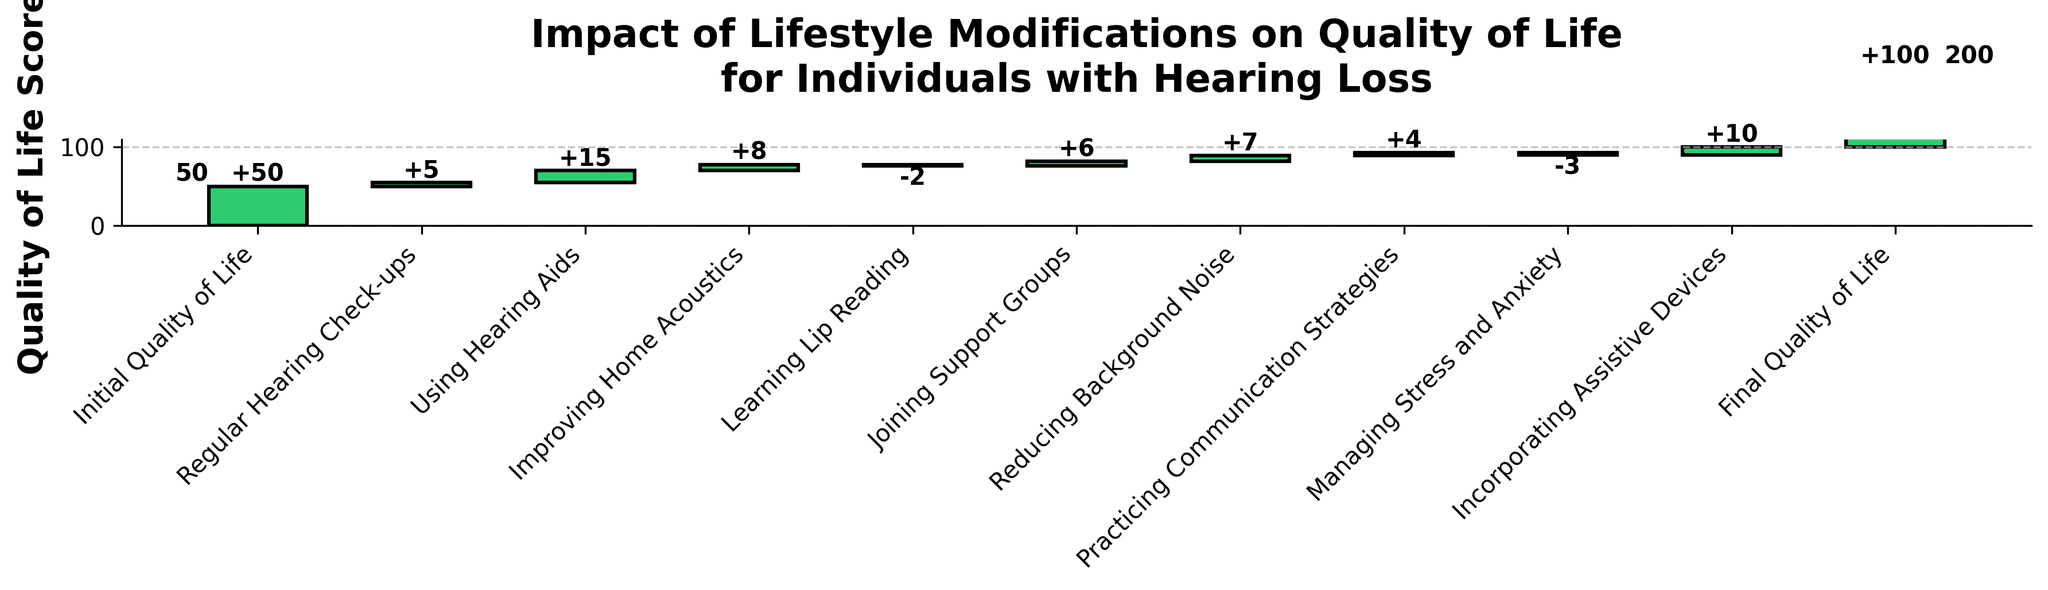What is the title of the chart? The title of the chart is usually placed at the top of the figure. It provides an overview of what the chart is about. In this case, the title is "Impact of Lifestyle Modifications on Quality of Life for Individuals with Hearing Loss".
Answer: Impact of Lifestyle Modifications on Quality of Life for Individuals with Hearing Loss How many steps are shown in the waterfall chart? Count the number of steps listed on the x-axis. Each step represents a different modification.
Answer: 10 What is the total improvement in Quality of Life Score from "Using Hearing Aids"? Look for the bar labeled "Using Hearing Aids" and identify the value associated with it. The value is indicated as +15.
Answer: +15 Which modification has a negative impact on the Quality of Life Score? Identify the bars that show a negative impact by their color (usually red) and check their labels. In this chart, "Learning Lip Reading" and "Managing Stress and Anxiety" are negative impacts.
Answer: Learning Lip Reading and Managing Stress and Anxiety What is the final Quality of Life Score after all the modifications? Look at the cumulative final value at the end of the waterfall chart. This value is labeled at the top of the final bar.
Answer: 100 How does the impact of "Incorporating Assistive Devices" compare to "Reducing Background Noise"? Identify the values for both modifications and compare them. "Incorporating Assistive Devices" has an impact of +10, while "Reducing Background Noise" has an impact of +7.
Answer: Incorporating Assistive Devices has a greater impact What is the combined impact of "Using Hearing Aids" and "Incorporating Assistive Devices"? Add the individual impacts of "Using Hearing Aids" (+15) and "Incorporating Assistive Devices" (+10) together.
Answer: +25 How does "Practicing Communication Strategies" affect the Quality of Life Score? Locate the bar labeled "Practicing Communication Strategies" and find its impact value. It is shown as +4.
Answer: +4 What is the impact of regular hearing check-ups on the score? Look for the bar labeled "Regular Hearing Check-ups" and identify its impact value. It is shown as +5.
Answer: +5 Which step contributes most positively to the Quality of Life Score? Identify the bar with the highest positive impact value. "Using Hearing Aids" has the highest impact with +15.
Answer: Using Hearing Aids 